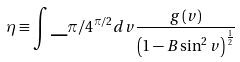Convert formula to latex. <formula><loc_0><loc_0><loc_500><loc_500>\eta \equiv \int \_ { \pi / 4 } ^ { \pi / 2 } d v \frac { g \left ( v \right ) } { \left ( 1 - B \sin ^ { 2 } v \right ) ^ { \frac { 1 } { 2 } } }</formula> 